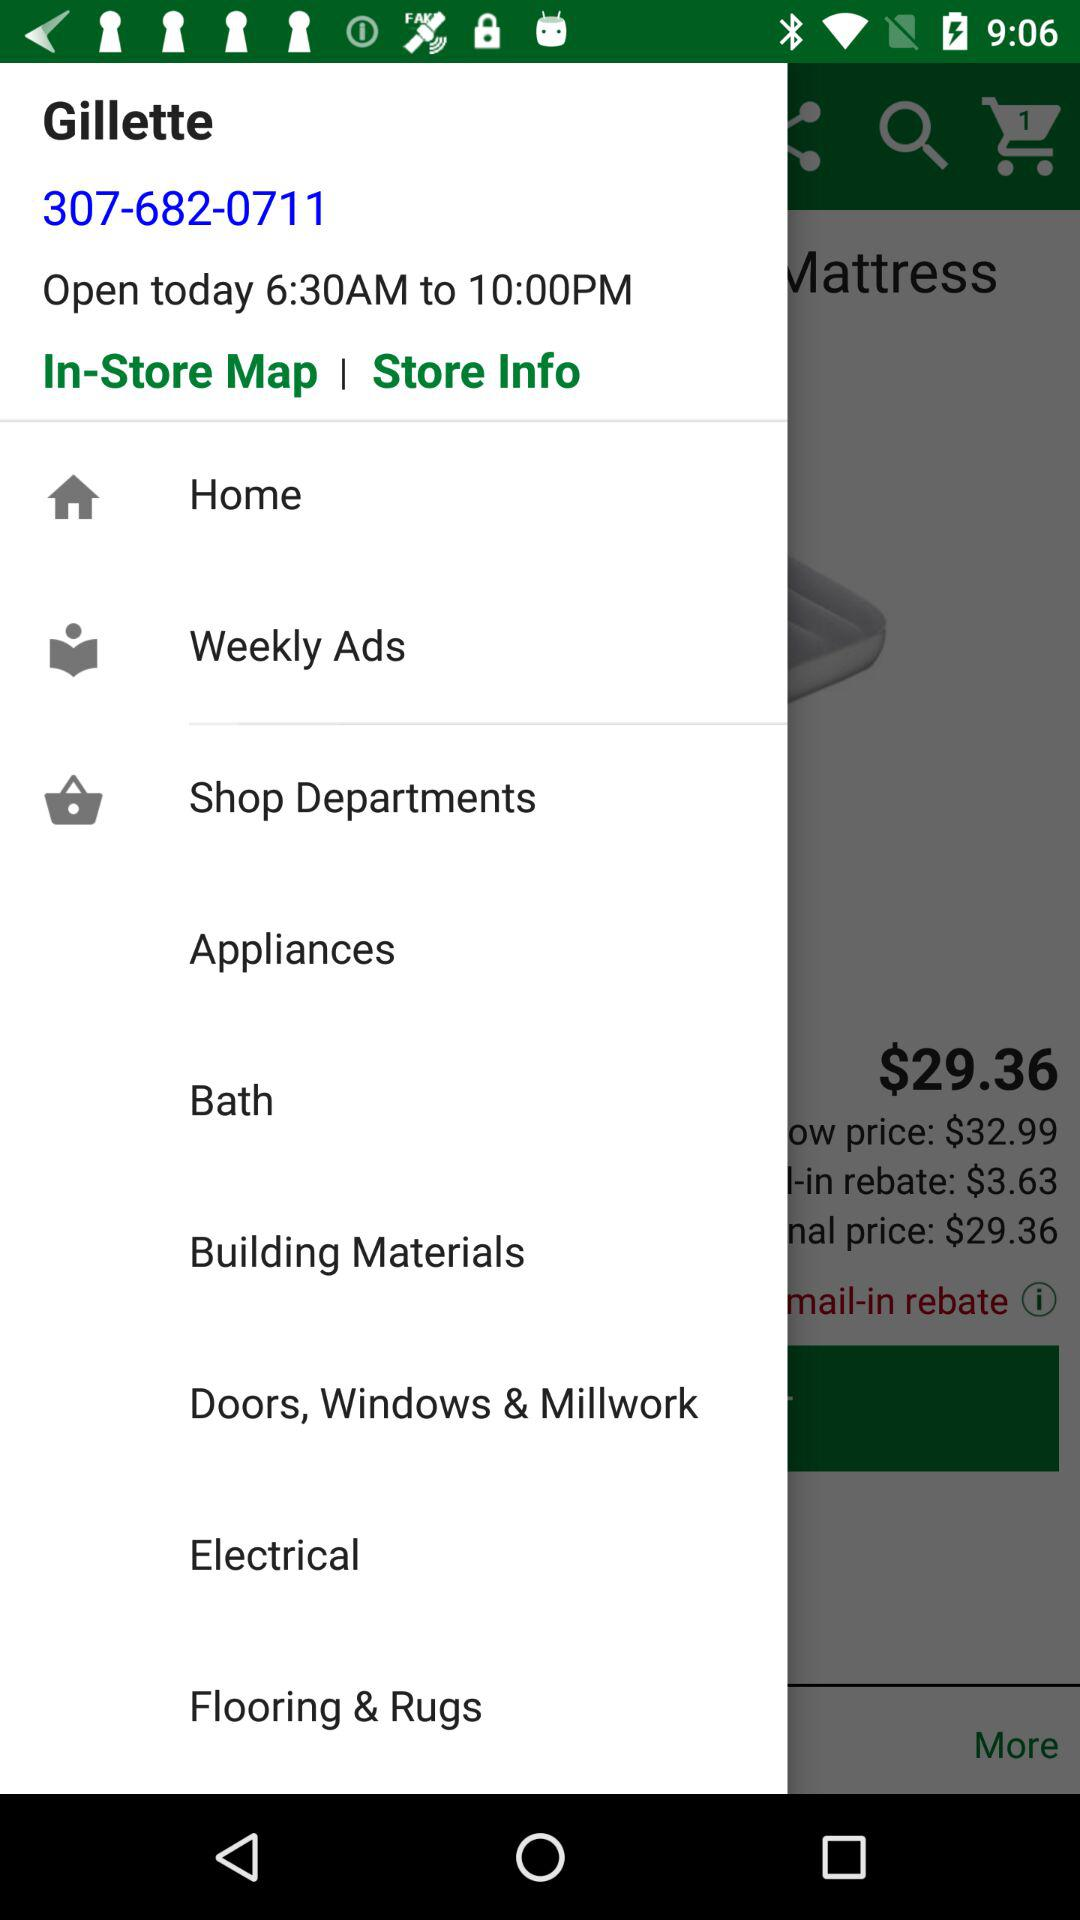How much is the price of the mattress topper after the mail-in rebate?
Answer the question using a single word or phrase. $29.36 